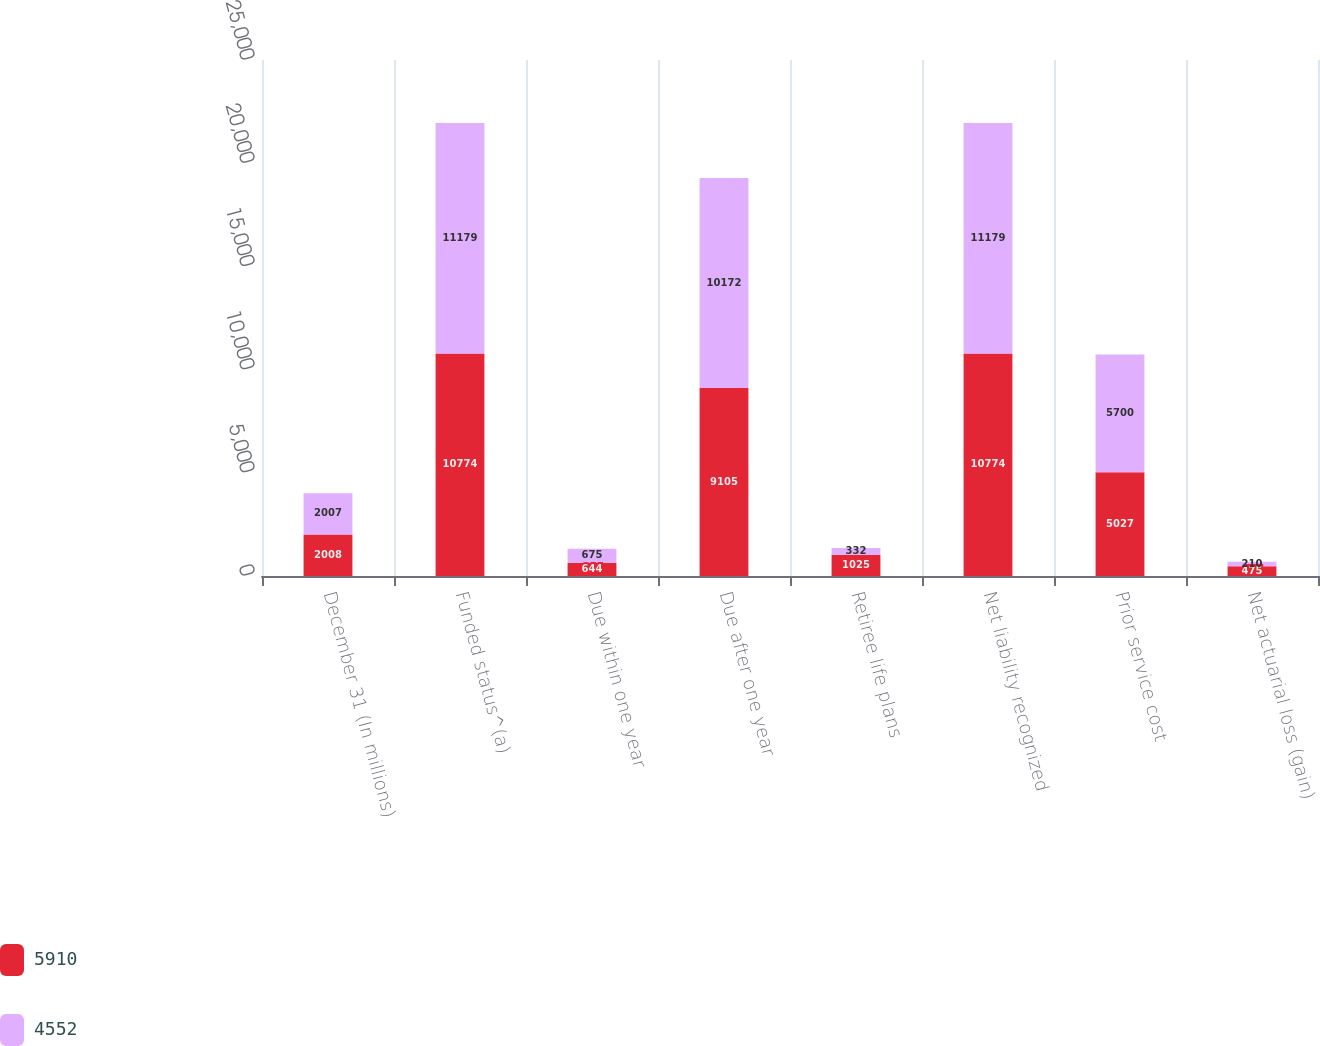Convert chart to OTSL. <chart><loc_0><loc_0><loc_500><loc_500><stacked_bar_chart><ecel><fcel>December 31 (In millions)<fcel>Funded status^(a)<fcel>Due within one year<fcel>Due after one year<fcel>Retiree life plans<fcel>Net liability recognized<fcel>Prior service cost<fcel>Net actuarial loss (gain)<nl><fcel>5910<fcel>2008<fcel>10774<fcel>644<fcel>9105<fcel>1025<fcel>10774<fcel>5027<fcel>475<nl><fcel>4552<fcel>2007<fcel>11179<fcel>675<fcel>10172<fcel>332<fcel>11179<fcel>5700<fcel>210<nl></chart> 